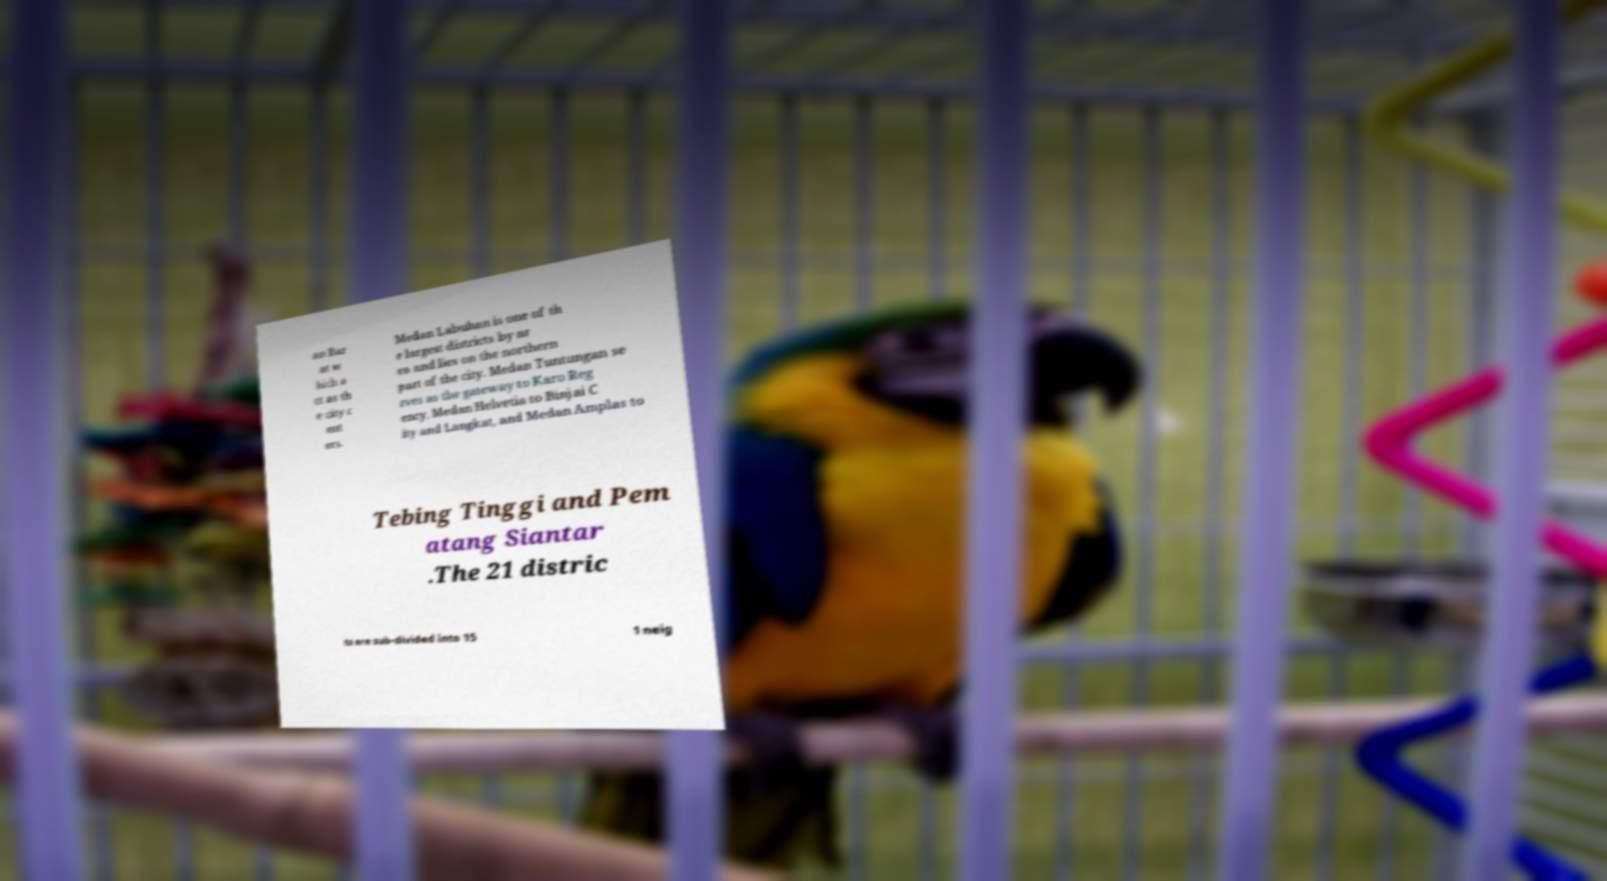Can you accurately transcribe the text from the provided image for me? an Bar at w hich a ct as th e city c ent ers. Medan Labuhan is one of th e largest districts by ar ea and lies on the northern part of the city. Medan Tuntungan se rves as the gateway to Karo Reg ency, Medan Helvetia to Binjai C ity and Langkat, and Medan Amplas to Tebing Tinggi and Pem atang Siantar .The 21 distric ts are sub-divided into 15 1 neig 